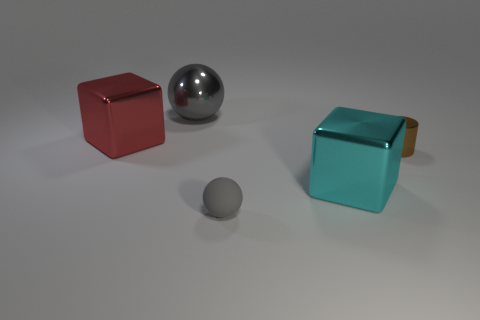Are there any other large balls that have the same color as the rubber ball?
Ensure brevity in your answer.  Yes. There is a metal object that is the same color as the matte sphere; what is its size?
Give a very brief answer. Large. Does the rubber sphere have the same size as the brown object?
Offer a very short reply. Yes. What number of red blocks are behind the rubber object?
Offer a terse response. 1. Are there an equal number of big gray metal things behind the cyan shiny object and large things that are on the left side of the big red metallic block?
Provide a succinct answer. No. There is a large metal thing in front of the metallic cylinder; is its shape the same as the tiny matte object?
Your answer should be compact. No. Is there anything else that has the same material as the small gray object?
Provide a short and direct response. No. There is a red block; does it have the same size as the gray object that is behind the small cylinder?
Make the answer very short. Yes. How many other objects are there of the same color as the metal ball?
Make the answer very short. 1. There is a tiny matte object; are there any gray balls left of it?
Provide a succinct answer. Yes. 